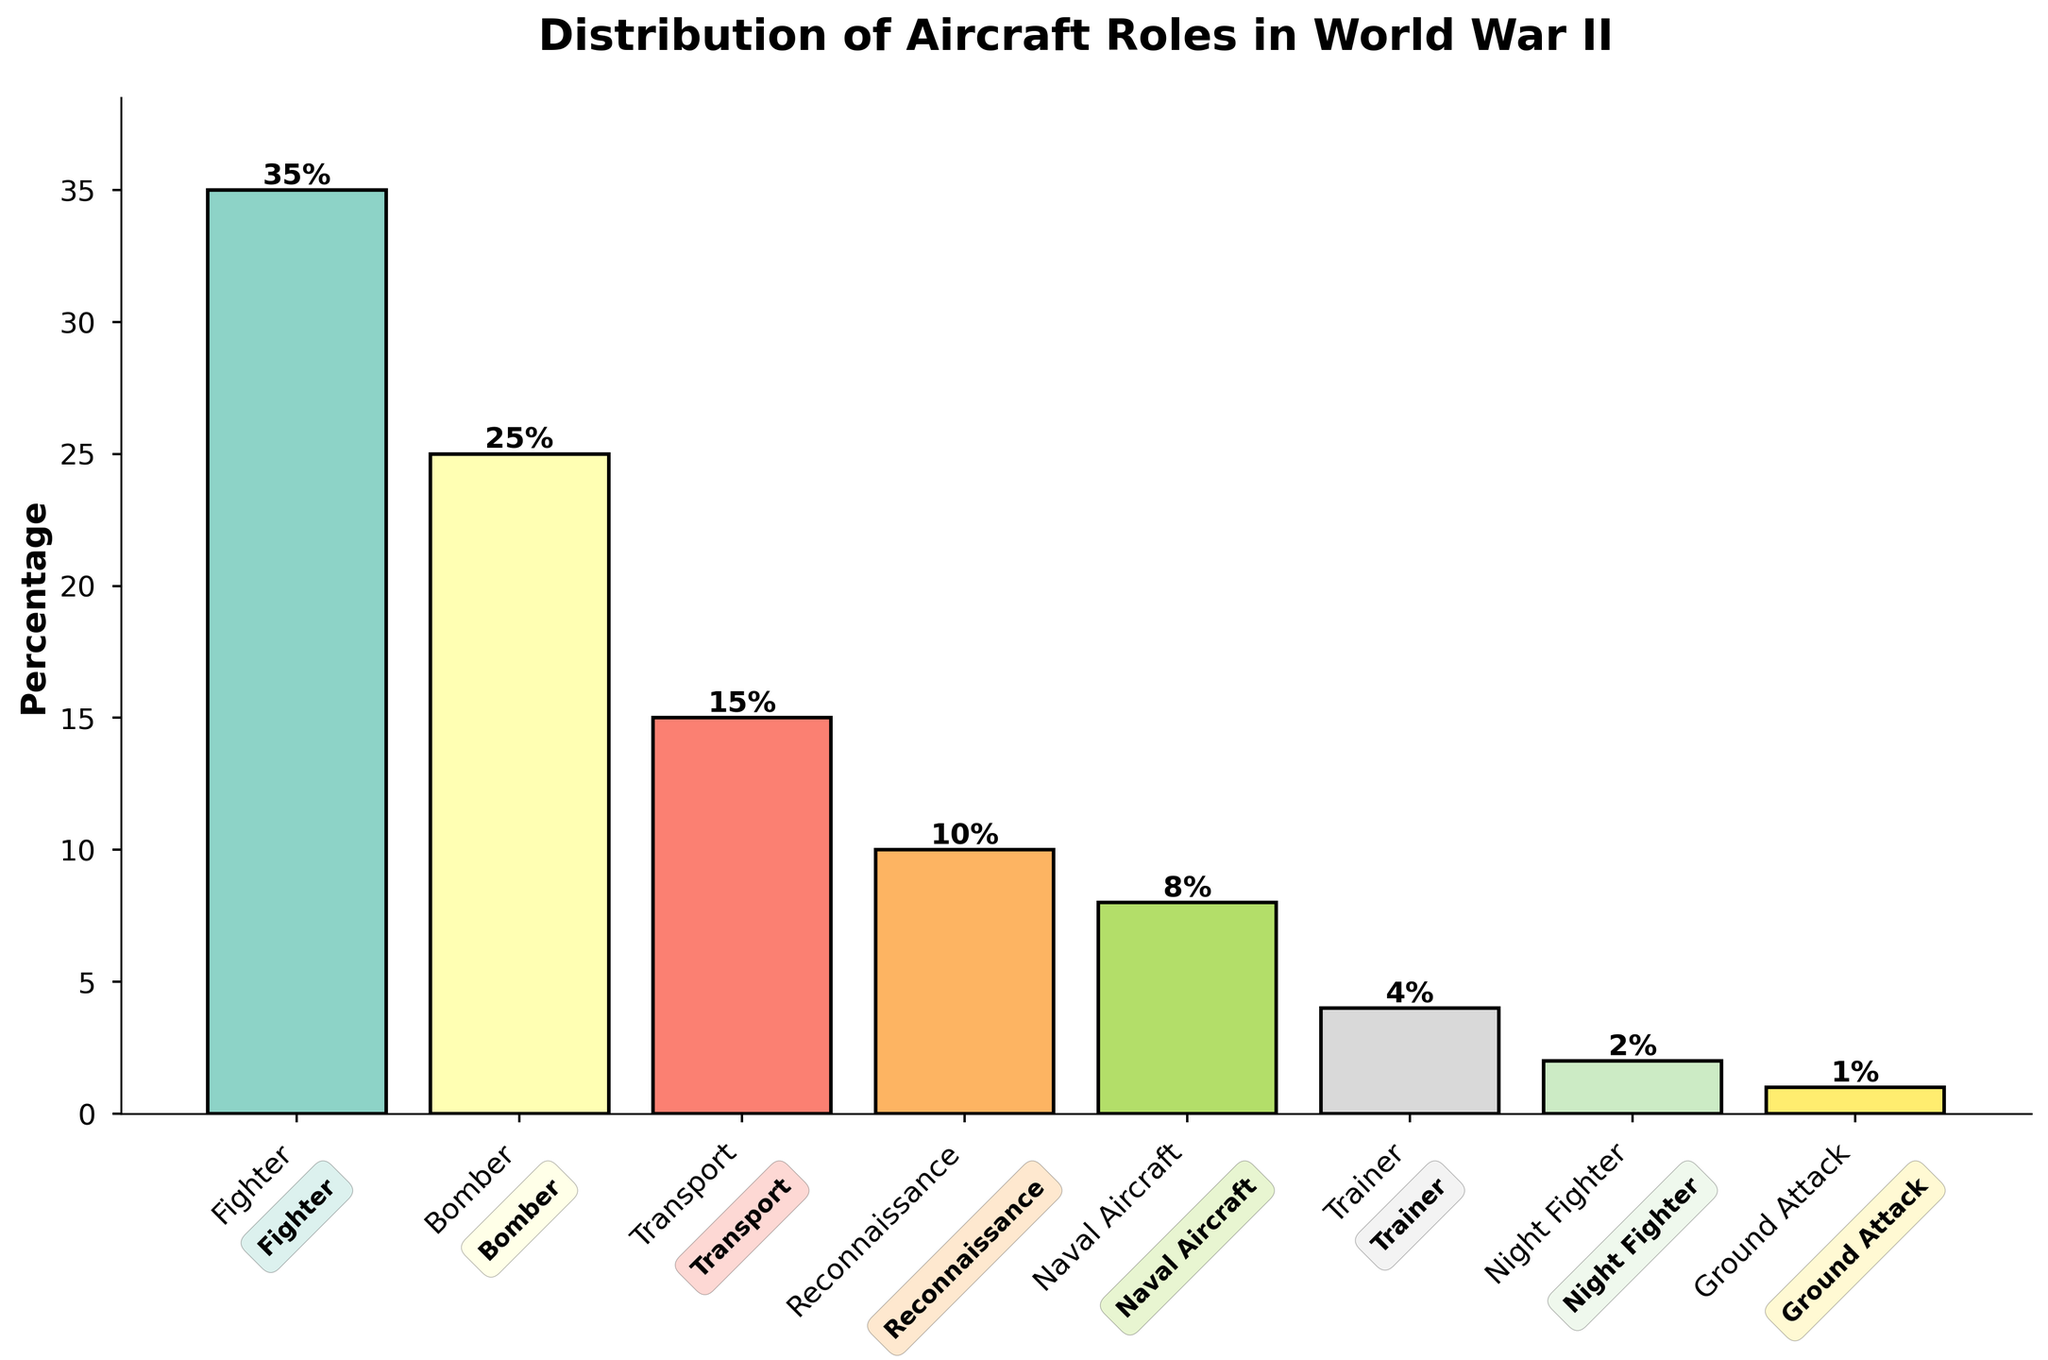What is the percentage of Fighter aircraft? The bar labeled "Fighter" shows a height corresponding to 35%. This means that Fighter aircraft made up 35% of the distribution.
Answer: 35% What is the sum of the percentages for Fighter and Bomber aircraft? Add the percentages for Fighter (35%) and Bomber (25%). The sum is 35% + 25% = 60%.
Answer: 60% Which aircraft role has the smallest percentage? The shortest bar in the chart represents Ground Attack, which has a percentage of 1%.
Answer: Ground Attack How much larger is the percentage of Reconnaissance aircraft compared to Naval Aircraft? Reconnaissance aircraft have a percentage of 10%, and Naval Aircraft have a percentage of 8%. The difference is 10% - 8% = 2%.
Answer: 2% What is the combined percentage of Night Fighter and Ground Attack aircraft? Add the percentages for Night Fighter (2%) and Ground Attack (1%). The combined percentage is 2% + 1% = 3%.
Answer: 3% Which two aircraft roles have their combined percentage equal to the percentage of Transport aircraft? Transport aircraft have a percentage of 15%. Adding the percentages of Trainer (4%) and Naval Aircraft (8%) gives 4% + 8% = 12%, which doesn't match. However, Reconnaissance (10%) and Trainer (4%) give a suitable sum: 10% + 4% = 14%, which still doesn't fit. Combining Bomber (25%) and Night Fighter (2%) results in 15%, matching the percentage for Transport.
Answer: Bomber and Night Fighter Which aircraft role has more than double the percentage of the Night Fighter role? Night Fighter has a percentage of 2%. Doubling this gives 4%. Fighter (35%), Bomber (25%), Transport (15%), Reconnaissance (10%), and Naval Aircraft (8%) all have more than double that amount.
Answer: Fighter, Bomber, Transport, Reconnaissance, Naval Aircraft What is the difference between the percentage of Fighter and Ground Attack aircraft? The percentage for Fighter aircraft is 35%, and for Ground Attack aircraft, it is 1%. The difference is 35% - 1% = 34%.
Answer: 34% What is the average percentage of Naval Aircraft and Trainer aircraft? The percentages for Naval Aircraft and Trainer aircraft are 8% and 4%, respectively. The average is (8% + 4%) / 2 = 12% / 2 = 6%.
Answer: 6% 